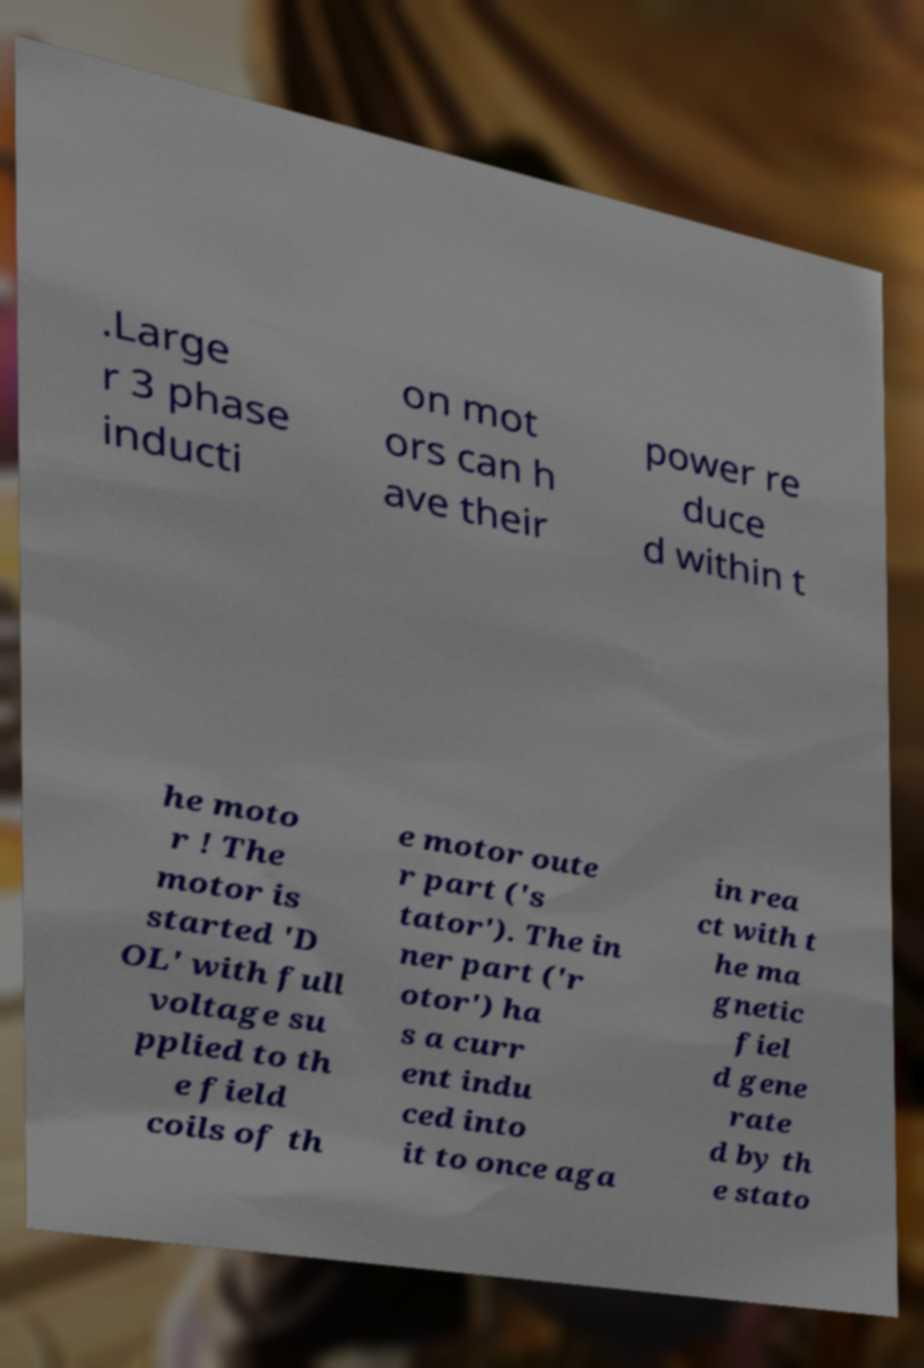Can you accurately transcribe the text from the provided image for me? .Large r 3 phase inducti on mot ors can h ave their power re duce d within t he moto r ! The motor is started 'D OL' with full voltage su pplied to th e field coils of th e motor oute r part ('s tator'). The in ner part ('r otor') ha s a curr ent indu ced into it to once aga in rea ct with t he ma gnetic fiel d gene rate d by th e stato 